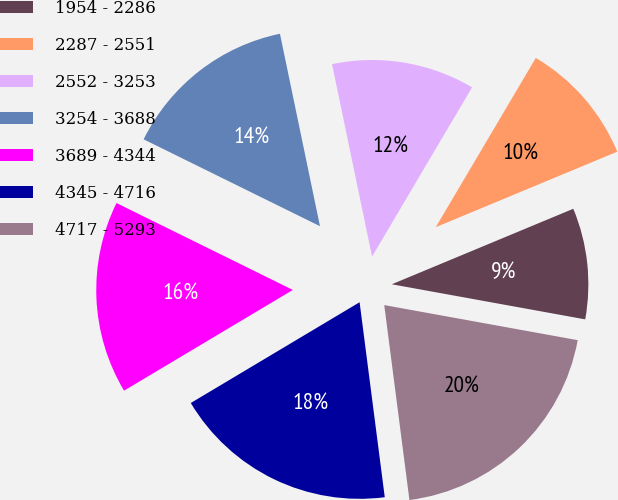Convert chart. <chart><loc_0><loc_0><loc_500><loc_500><pie_chart><fcel>1954 - 2286<fcel>2287 - 2551<fcel>2552 - 3253<fcel>3254 - 3688<fcel>3689 - 4344<fcel>4345 - 4716<fcel>4717 - 5293<nl><fcel>9.13%<fcel>10.23%<fcel>11.76%<fcel>14.45%<fcel>15.85%<fcel>18.48%<fcel>20.1%<nl></chart> 